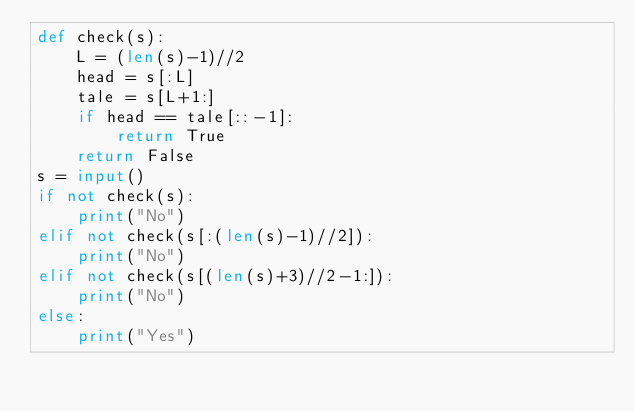<code> <loc_0><loc_0><loc_500><loc_500><_Python_>def check(s):
    L = (len(s)-1)//2
    head = s[:L]
    tale = s[L+1:]
    if head == tale[::-1]:
        return True
    return False
s = input()
if not check(s):
    print("No")
elif not check(s[:(len(s)-1)//2]):
    print("No")
elif not check(s[(len(s)+3)//2-1:]):
    print("No")
else:
    print("Yes")</code> 